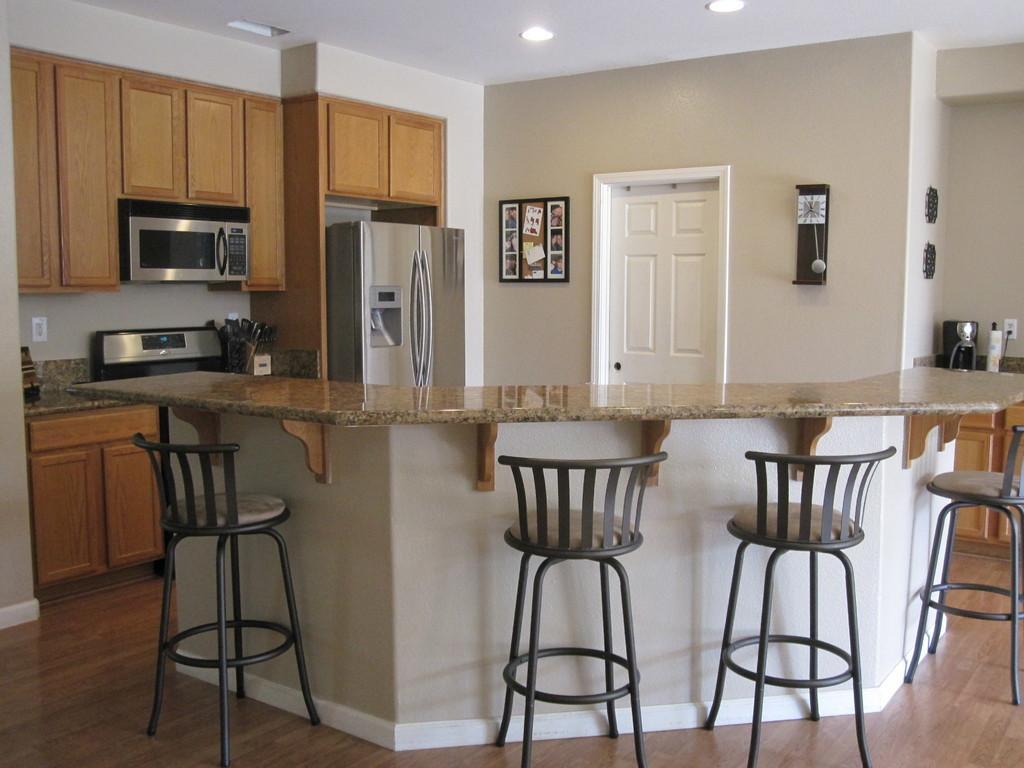Can you describe this image briefly? In this picture I can see kitchen table and chairs. In the background I can see white color door and wall on which I can see clock and other objects attached to it. On the left side I can see microwave oven, refrigerator and wooden cupboards. On the right side I can see some objects. 